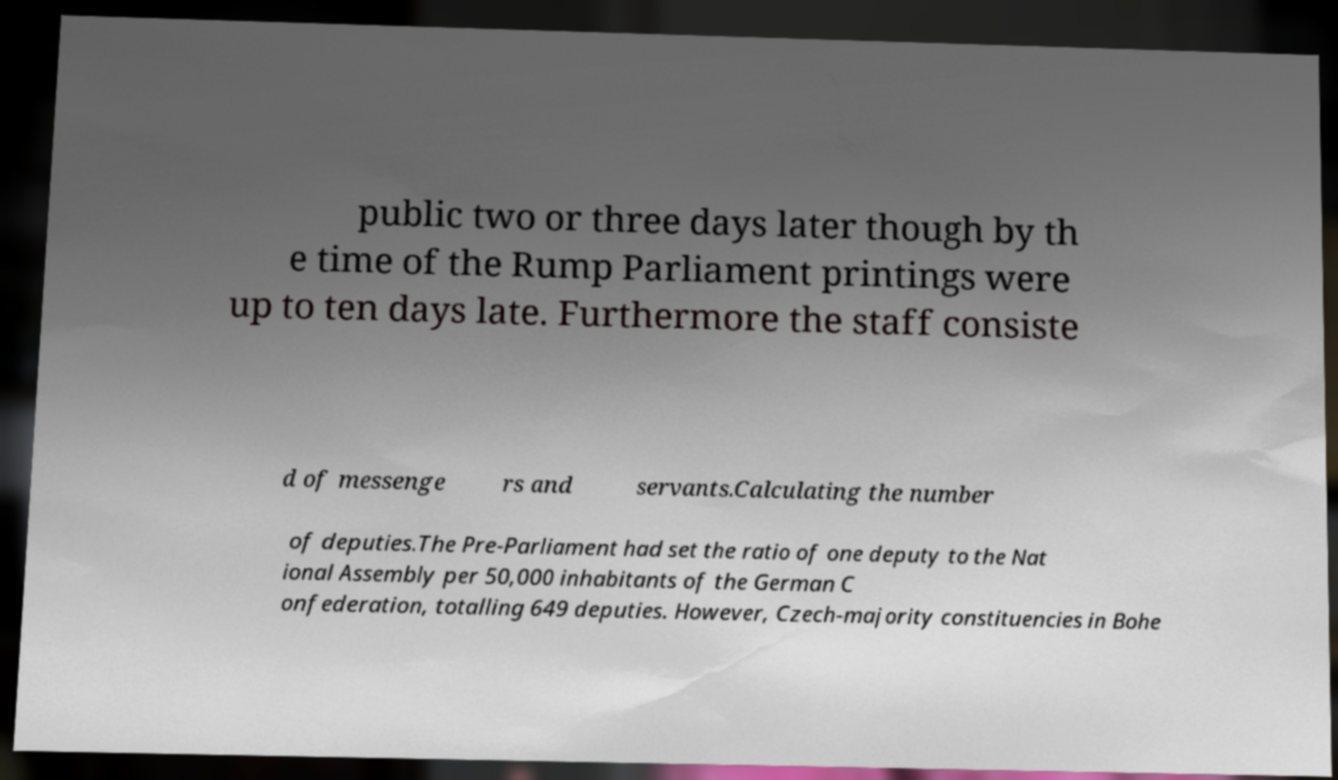Could you assist in decoding the text presented in this image and type it out clearly? public two or three days later though by th e time of the Rump Parliament printings were up to ten days late. Furthermore the staff consiste d of messenge rs and servants.Calculating the number of deputies.The Pre-Parliament had set the ratio of one deputy to the Nat ional Assembly per 50,000 inhabitants of the German C onfederation, totalling 649 deputies. However, Czech-majority constituencies in Bohe 